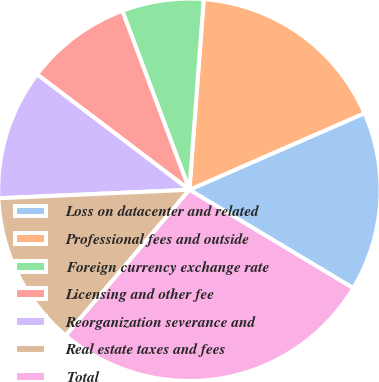Convert chart to OTSL. <chart><loc_0><loc_0><loc_500><loc_500><pie_chart><fcel>Loss on datacenter and related<fcel>Professional fees and outside<fcel>Foreign currency exchange rate<fcel>Licensing and other fee<fcel>Reorganization severance and<fcel>Real estate taxes and fees<fcel>Total<nl><fcel>15.17%<fcel>17.24%<fcel>6.9%<fcel>8.97%<fcel>11.03%<fcel>13.1%<fcel>27.59%<nl></chart> 